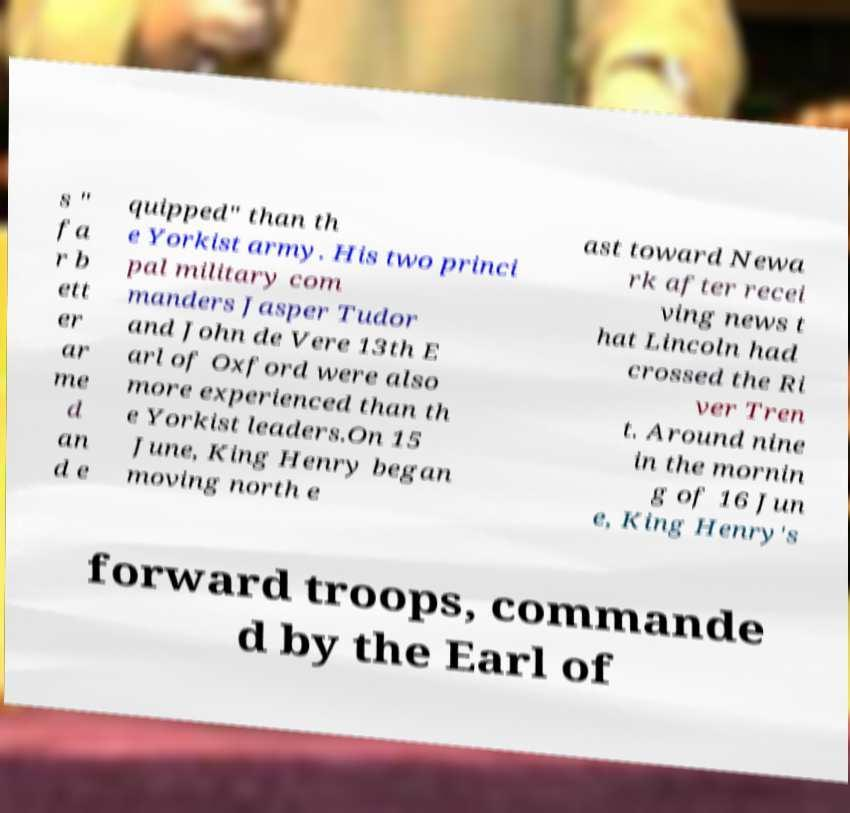Could you extract and type out the text from this image? s " fa r b ett er ar me d an d e quipped" than th e Yorkist army. His two princi pal military com manders Jasper Tudor and John de Vere 13th E arl of Oxford were also more experienced than th e Yorkist leaders.On 15 June, King Henry began moving north e ast toward Newa rk after recei ving news t hat Lincoln had crossed the Ri ver Tren t. Around nine in the mornin g of 16 Jun e, King Henry's forward troops, commande d by the Earl of 